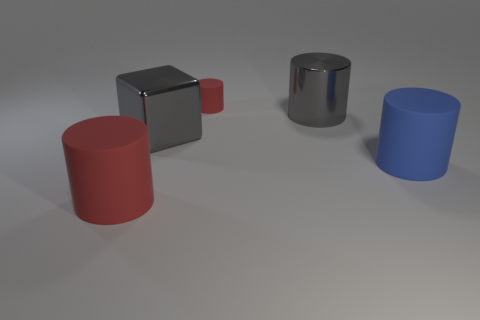Subtract all gray cylinders. How many cylinders are left? 3 Subtract all gray cylinders. How many cylinders are left? 3 Subtract all blocks. How many objects are left? 4 Add 3 tiny red cylinders. How many objects exist? 8 Subtract all green matte cubes. Subtract all large gray cylinders. How many objects are left? 4 Add 5 large blue cylinders. How many large blue cylinders are left? 6 Add 1 red cylinders. How many red cylinders exist? 3 Subtract 0 blue spheres. How many objects are left? 5 Subtract 1 blocks. How many blocks are left? 0 Subtract all gray cylinders. Subtract all cyan balls. How many cylinders are left? 3 